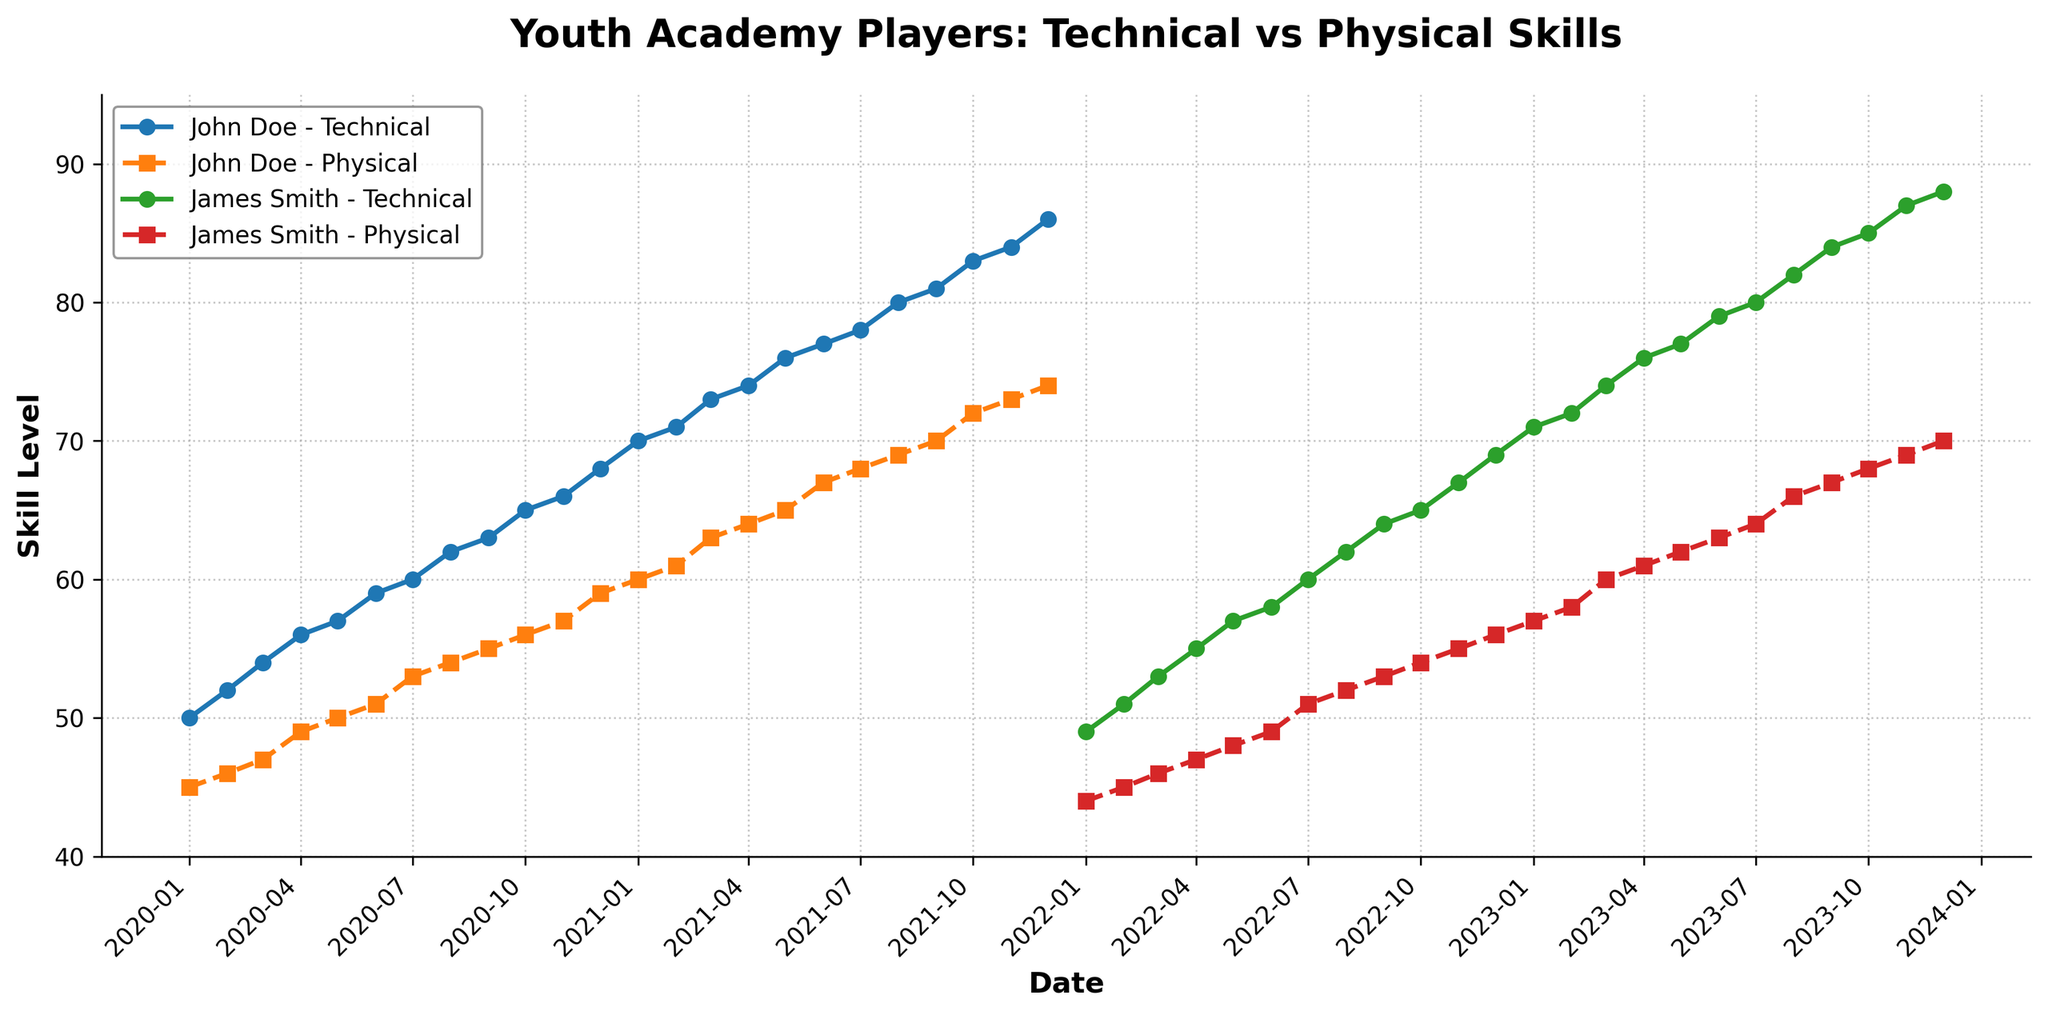What is the title of the plot? The title of the plot is at the top and is usually bold and larger than the other text. Here it says "Youth Academy Players: Technical vs Physical Skills".
Answer: Youth Academy Players: Technical vs Physical Skills When did John Doe's technical skill first reach 70? Following the line for John Doe's Technical_Skill and looking for the point where it reaches 70, you see it happens around January 2021.
Answer: January 2021 How many players' data are presented in the plot? Each unique legend entry with a player's name indicates their data usage in the plot. In this case, there are two players: John Doe and James Smith.
Answer: 2 Which player's skill data covers more months, John Doe or James Smith? John Doe's data starts in January 2020 and ends in December 2021, spanning 24 months. James Smith's data spans from January 2022 to December 2023, also covering 24 months. Both have data for the same number of months.
Answer: Both What is the highest recorded technical skill level for James Smith? Following the trend of James Smith's Technical_Skill line and looking at the highest point on that line, it reaches 88 in December 2023.
Answer: 88 Does physical skill or technical skill improve faster for John Doe? Compare the slope of the lines representing both skills for John Doe. The Technical_Skill line shows a steeper ascent compared to the Physical_Skill line, indicating that technical skill improves faster.
Answer: Technical skill By how much did James Smith's physical skill increase from January 2022 to January 2023? Look at the Physical_Skill value in January 2022 (44) and January 2023 (57). The difference is 57 - 44 = 13.
Answer: 13 Compare the technical skill levels of both players in their first recorded month. Who started higher? In January 2020, John Doe has 50 Technical_Skill; in January 2022, James Smith has 49. John Doe started higher.
Answer: John Doe In December 2021, how does the physical skill of John Doe compare to the physical skill of James Smith in December 2023? John Doe's Physical_Skill in December 2021 is 74; James Smith's Physical_Skill in December 2023 is 70. John Doe's skill is higher.
Answer: John Doe What is the average technical skill level of John Doe in the first six months of 2021? Sum the values from January to June 2021: 70 + 71 + 73 + 74 + 76 + 77 = 441, then divide by 6.
Answer: 441/6 ≈ 73.5 